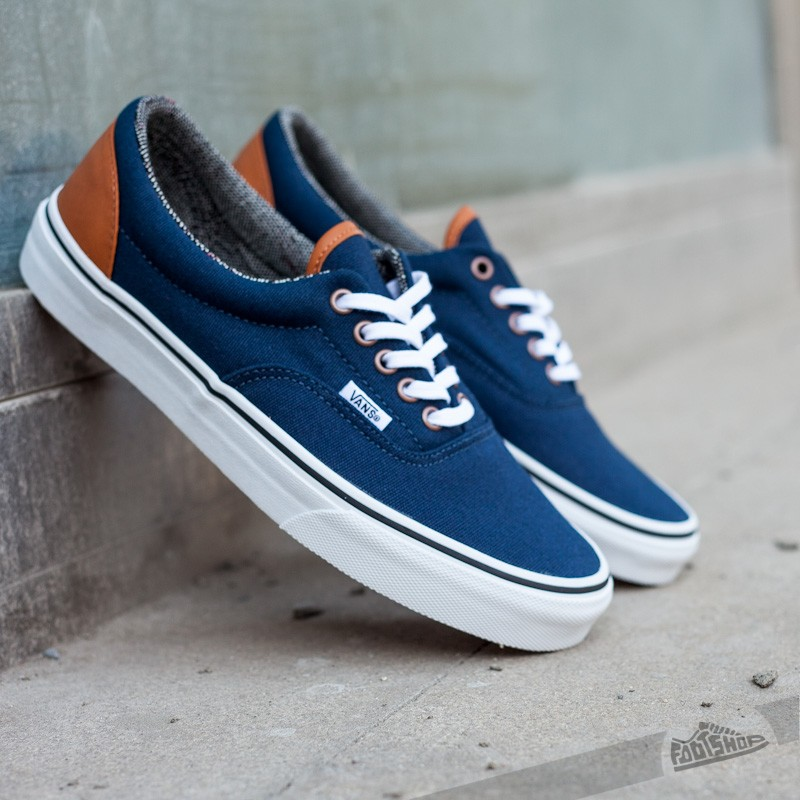Imagine you found these sneakers in a magical thrift store that grants wishes. What would you wish for when you buy them? Upon finding these sneakers in a magical thrift store, a sense of wonder and excitement fills your heart. As you try them on, the storekeeper, a mysterious and kind old man, reveals that these sneakers have the power to grant one wish to their new owner. Contemplating the possibilities, you imagine all sorts of desires: adventure, knowledge, peace. Finally, with the sneakers snug on your feet, you make your wish: 'I wish for the ability to bring joy and inspiration to everyone I meet.' Suddenly, a warm glow surrounds you, and you feel a surge of energy. From that day forward, the sneakers, now enchanted with your wish, seem to radiate positivity. Wherever you go, smiles light up, laughter fills the air, and people's spirits are lifted. Your simple wish, granted through these magical sneakers, spreads happiness far and wide. 